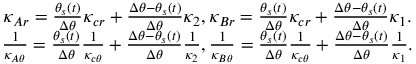<formula> <loc_0><loc_0><loc_500><loc_500>\begin{array} { c } { \kappa _ { A r } = \frac { \theta _ { s } ( t ) } { \Delta \theta } \kappa _ { c r } + \frac { \Delta \theta - \theta _ { s } ( t ) } { \Delta \theta } \kappa _ { 2 } , \kappa _ { B r } = \frac { \theta _ { s } ( t ) } { \Delta \theta } \kappa _ { c r } + \frac { \Delta \theta - \theta _ { s } ( t ) } { \Delta \theta } \kappa _ { 1 } . } \\ { \frac { 1 } { \kappa _ { A \theta } } = \frac { \theta _ { s } ( t ) } { \Delta \theta } \frac { 1 } { \kappa _ { c \theta } } + \frac { \Delta \theta - \theta _ { s } ( t ) } { \Delta \theta } \frac { 1 } { \kappa _ { 2 } } , \frac { 1 } { \kappa _ { B \theta } } = \frac { \theta _ { s } ( t ) } { \Delta \theta } \frac { 1 } { \kappa _ { c \theta } } + \frac { \Delta \theta - \theta _ { s } ( t ) } { \Delta \theta } \frac { 1 } { \kappa _ { 1 } } . } \end{array}</formula> 